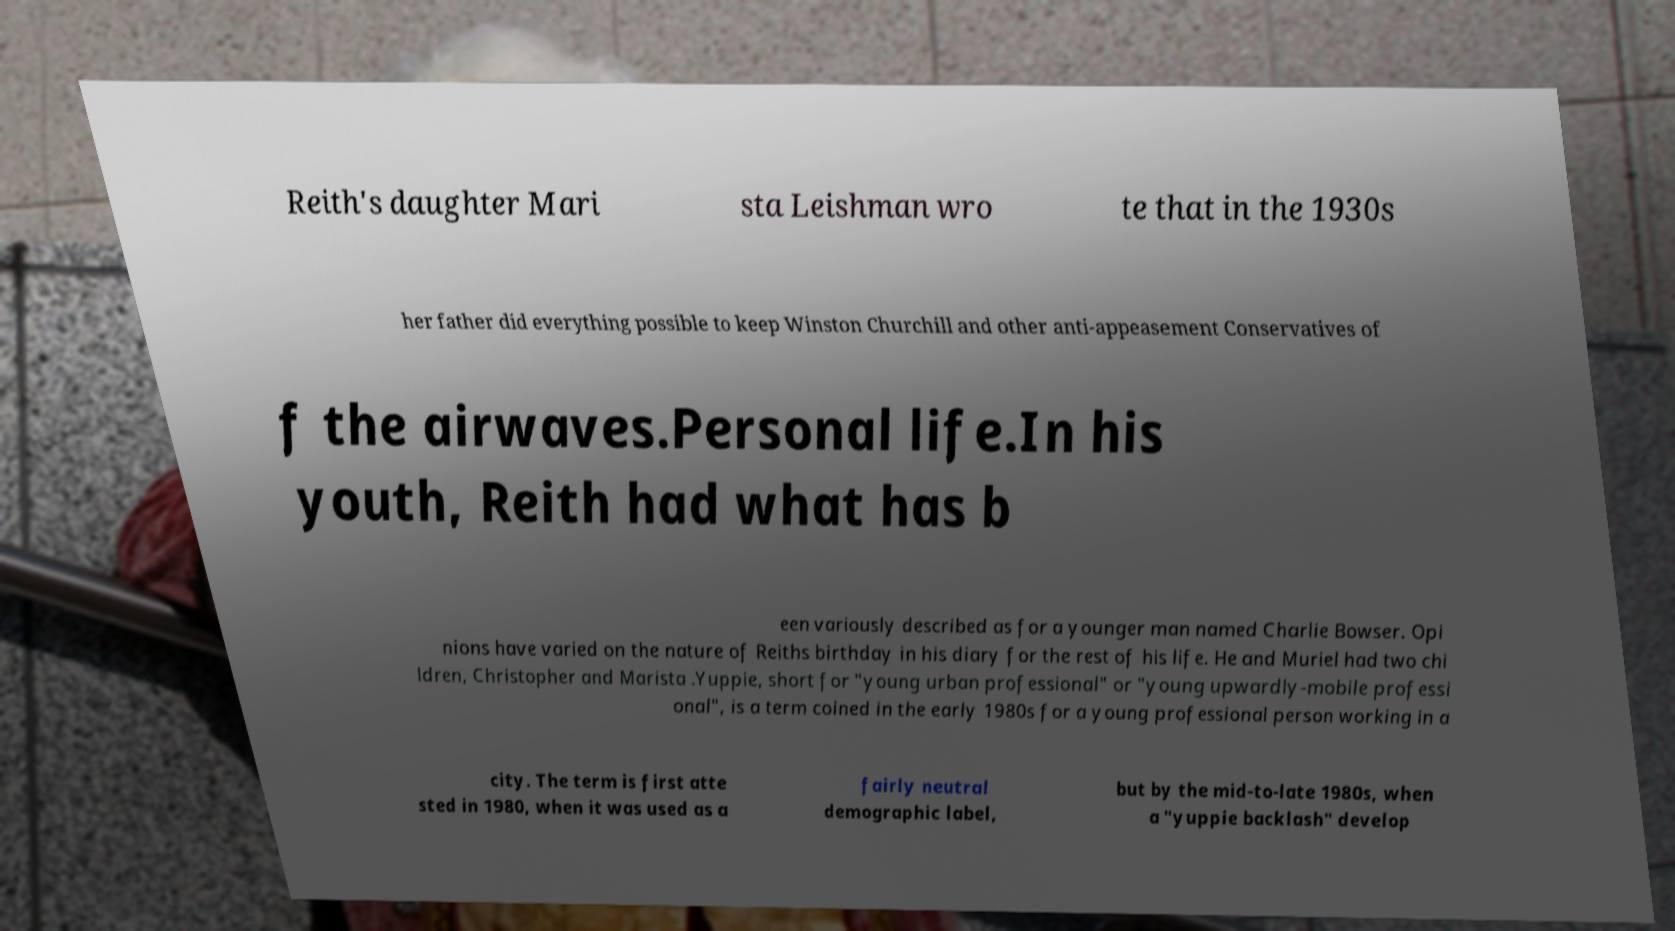I need the written content from this picture converted into text. Can you do that? Reith's daughter Mari sta Leishman wro te that in the 1930s her father did everything possible to keep Winston Churchill and other anti-appeasement Conservatives of f the airwaves.Personal life.In his youth, Reith had what has b een variously described as for a younger man named Charlie Bowser. Opi nions have varied on the nature of Reiths birthday in his diary for the rest of his life. He and Muriel had two chi ldren, Christopher and Marista .Yuppie, short for "young urban professional" or "young upwardly-mobile professi onal", is a term coined in the early 1980s for a young professional person working in a city. The term is first atte sted in 1980, when it was used as a fairly neutral demographic label, but by the mid-to-late 1980s, when a "yuppie backlash" develop 